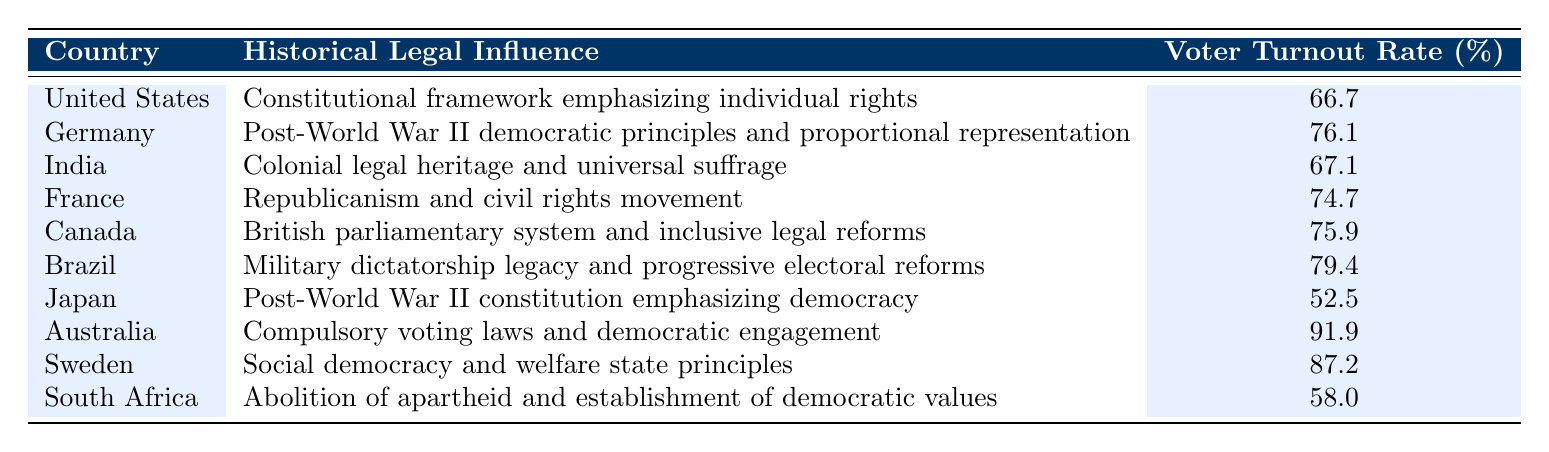What is the voter turnout rate for Australia? According to the table, Australia's voter turnout rate is provided directly under the appropriate heading. The information shows that it is 91.9%.
Answer: 91.9% Which country has the lowest voter turnout rate? The table lists the voter turnout rates for each country. By comparing these rates, Japan has the lowest rate at 52.5%.
Answer: Japan What is the difference in voter turnout rates between Sweden and South Africa? To find the difference between Sweden and South Africa's voter turnout rates, subtract South Africa's rate (58.0%) from Sweden's rate (87.2%). The calculation is 87.2 - 58.0 = 29.2.
Answer: 29.2 Is Brazil's historical legal influence related to its military dictatorship legacy? Yes, the table indicates Brazil’s historical legal influence as "Military dictatorship legacy and progressive electoral reforms," indicating a direct relationship between the legal history and its governance.
Answer: Yes What is the average voter turnout rate of the countries listed in the table? To find the average, sum all the voter turnout rates (66.7 + 76.1 + 67.1 + 74.7 + 75.9 + 79.4 + 52.5 + 91.9 + 87.2 + 58.0 = 789.5), and then divide by the total number of countries, which is 10. Thus, the average is 789.5 / 10 = 78.95.
Answer: 78.95 Which countries have a voter turnout rate above 75%? By reviewing the table, the countries with rates above 75% are Germany (76.1%), France (74.7%), Canada (75.9%), Brazil (79.4%), Australia (91.9%), and Sweden (87.2%). Thus, those six countries exceed the 75% threshold.
Answer: Germany, Canada, Brazil, Australia, Sweden Is there a country in the table where the historical legal influence mentions "universal suffrage"? Yes, India’s historical legal influence is noted as "Colonial legal heritage and universal suffrage," confirming that it includes a reference to universal suffrage.
Answer: Yes What are the voter turnout rates for countries with a historical legal influence related to democratic principles? The countries related to democratic principles are Germany (76.1%), Brazil (79.4%), Australia (91.9%), Sweden (87.2%), and South Africa (58.0%). The respective turnout rates are those values directly stated.
Answer: Germany 76.1, Brazil 79.4, Australia 91.9, Sweden 87.2, South Africa 58.0 